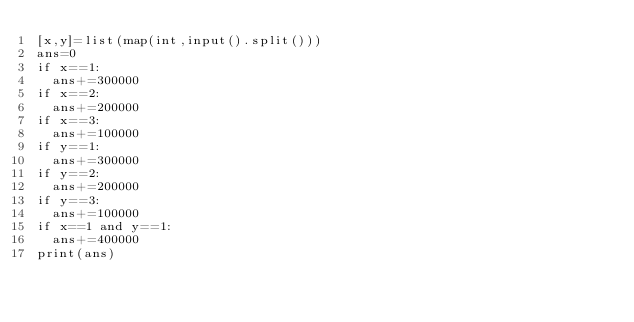<code> <loc_0><loc_0><loc_500><loc_500><_Python_>[x,y]=list(map(int,input().split()))
ans=0
if x==1:
	ans+=300000
if x==2:
	ans+=200000
if x==3:
	ans+=100000
if y==1:
	ans+=300000
if y==2:
	ans+=200000
if y==3:
	ans+=100000
if x==1 and y==1:
	ans+=400000
print(ans)</code> 